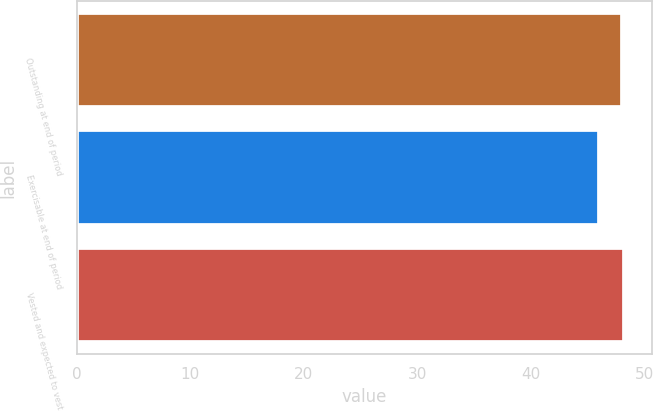<chart> <loc_0><loc_0><loc_500><loc_500><bar_chart><fcel>Outstanding at end of period<fcel>Exercisable at end of period<fcel>Vested and expected to vest<nl><fcel>48<fcel>46<fcel>48.2<nl></chart> 